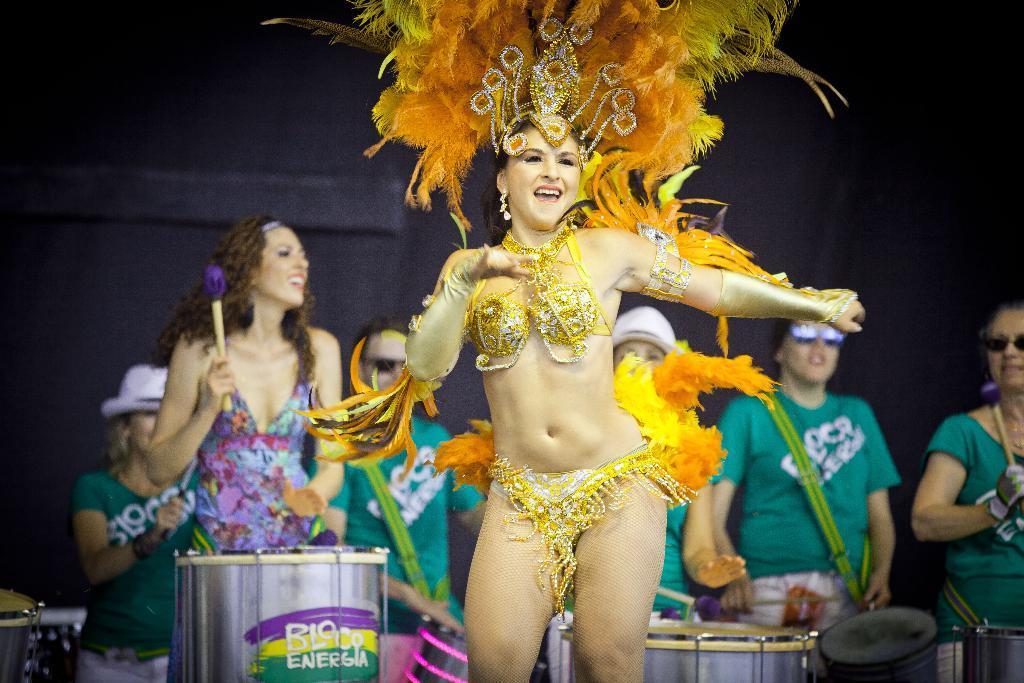How would you summarize this image in a sentence or two? In this image I can see few people are standing. I can also see she is wearing a costume. 